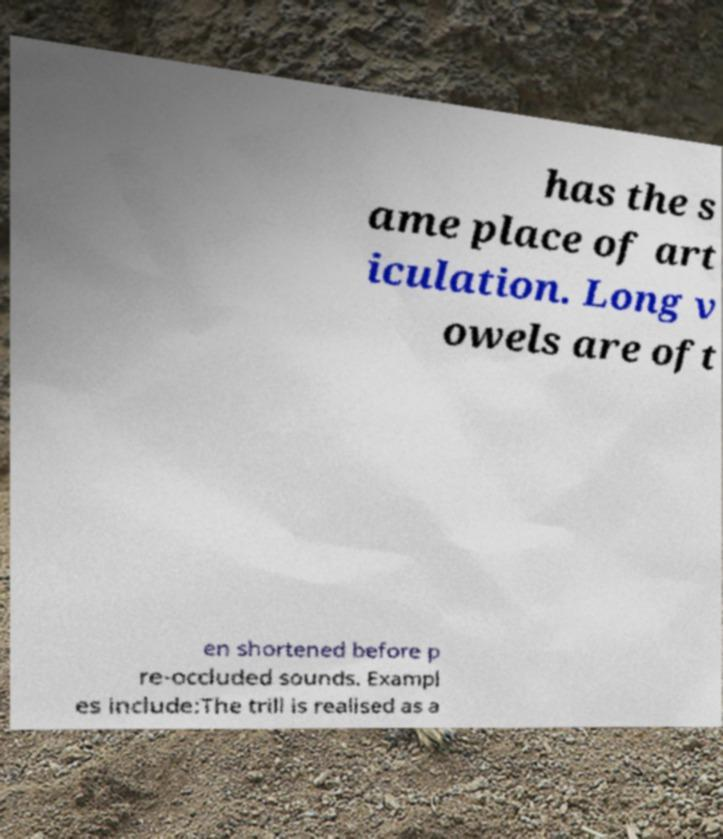Please read and relay the text visible in this image. What does it say? has the s ame place of art iculation. Long v owels are oft en shortened before p re-occluded sounds. Exampl es include:The trill is realised as a 